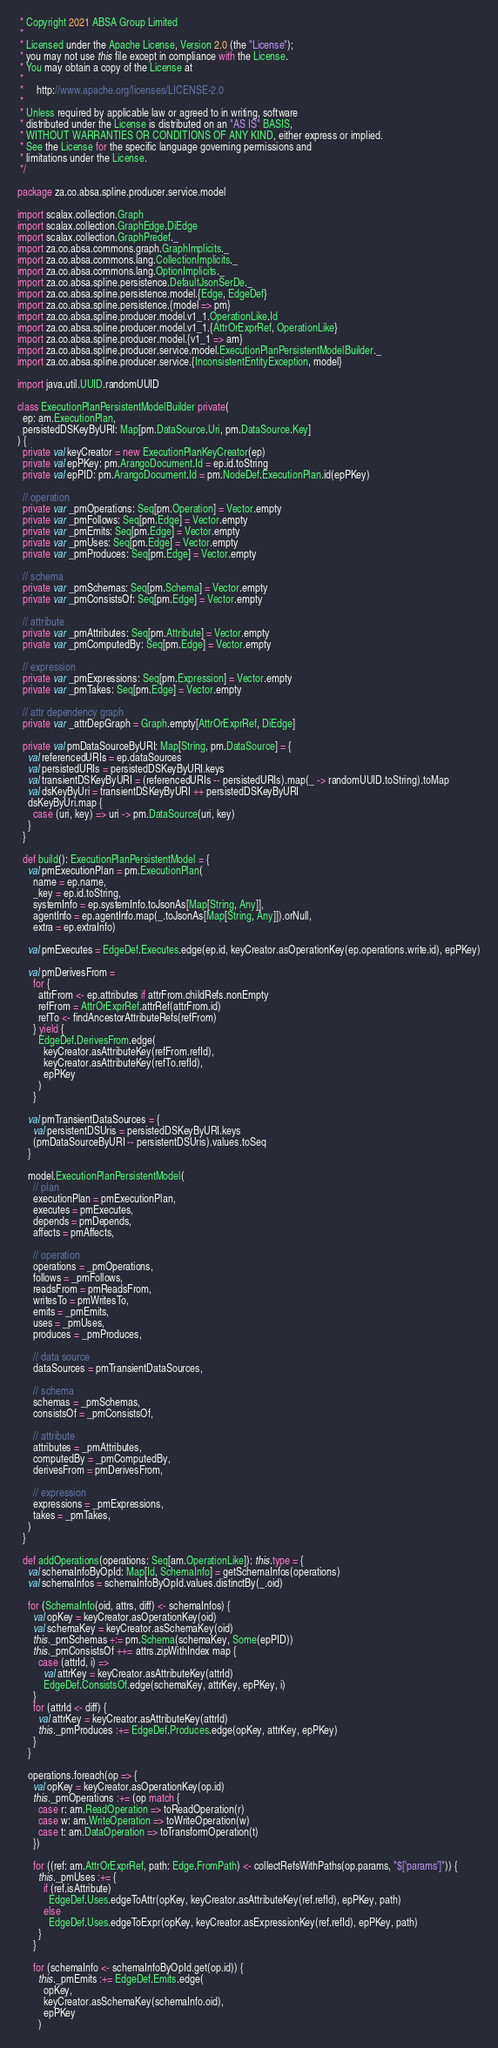<code> <loc_0><loc_0><loc_500><loc_500><_Scala_> * Copyright 2021 ABSA Group Limited
 *
 * Licensed under the Apache License, Version 2.0 (the "License");
 * you may not use this file except in compliance with the License.
 * You may obtain a copy of the License at
 *
 *     http://www.apache.org/licenses/LICENSE-2.0
 *
 * Unless required by applicable law or agreed to in writing, software
 * distributed under the License is distributed on an "AS IS" BASIS,
 * WITHOUT WARRANTIES OR CONDITIONS OF ANY KIND, either express or implied.
 * See the License for the specific language governing permissions and
 * limitations under the License.
 */

package za.co.absa.spline.producer.service.model

import scalax.collection.Graph
import scalax.collection.GraphEdge.DiEdge
import scalax.collection.GraphPredef._
import za.co.absa.commons.graph.GraphImplicits._
import za.co.absa.commons.lang.CollectionImplicits._
import za.co.absa.commons.lang.OptionImplicits._
import za.co.absa.spline.persistence.DefaultJsonSerDe._
import za.co.absa.spline.persistence.model.{Edge, EdgeDef}
import za.co.absa.spline.persistence.{model => pm}
import za.co.absa.spline.producer.model.v1_1.OperationLike.Id
import za.co.absa.spline.producer.model.v1_1.{AttrOrExprRef, OperationLike}
import za.co.absa.spline.producer.model.{v1_1 => am}
import za.co.absa.spline.producer.service.model.ExecutionPlanPersistentModelBuilder._
import za.co.absa.spline.producer.service.{InconsistentEntityException, model}

import java.util.UUID.randomUUID

class ExecutionPlanPersistentModelBuilder private(
  ep: am.ExecutionPlan,
  persistedDSKeyByURI: Map[pm.DataSource.Uri, pm.DataSource.Key]
) {
  private val keyCreator = new ExecutionPlanKeyCreator(ep)
  private val epPKey: pm.ArangoDocument.Id = ep.id.toString
  private val epPID: pm.ArangoDocument.Id = pm.NodeDef.ExecutionPlan.id(epPKey)

  // operation
  private var _pmOperations: Seq[pm.Operation] = Vector.empty
  private var _pmFollows: Seq[pm.Edge] = Vector.empty
  private var _pmEmits: Seq[pm.Edge] = Vector.empty
  private var _pmUses: Seq[pm.Edge] = Vector.empty
  private var _pmProduces: Seq[pm.Edge] = Vector.empty

  // schema
  private var _pmSchemas: Seq[pm.Schema] = Vector.empty
  private var _pmConsistsOf: Seq[pm.Edge] = Vector.empty

  // attribute
  private var _pmAttributes: Seq[pm.Attribute] = Vector.empty
  private var _pmComputedBy: Seq[pm.Edge] = Vector.empty

  // expression
  private var _pmExpressions: Seq[pm.Expression] = Vector.empty
  private var _pmTakes: Seq[pm.Edge] = Vector.empty

  // attr dependency graph
  private var _attrDepGraph = Graph.empty[AttrOrExprRef, DiEdge]

  private val pmDataSourceByURI: Map[String, pm.DataSource] = {
    val referencedURIs = ep.dataSources
    val persistedURIs = persistedDSKeyByURI.keys
    val transientDSKeyByURI = (referencedURIs -- persistedURIs).map(_ -> randomUUID.toString).toMap
    val dsKeyByUri = transientDSKeyByURI ++ persistedDSKeyByURI
    dsKeyByUri.map {
      case (uri, key) => uri -> pm.DataSource(uri, key)
    }
  }

  def build(): ExecutionPlanPersistentModel = {
    val pmExecutionPlan = pm.ExecutionPlan(
      name = ep.name,
      _key = ep.id.toString,
      systemInfo = ep.systemInfo.toJsonAs[Map[String, Any]],
      agentInfo = ep.agentInfo.map(_.toJsonAs[Map[String, Any]]).orNull,
      extra = ep.extraInfo)

    val pmExecutes = EdgeDef.Executes.edge(ep.id, keyCreator.asOperationKey(ep.operations.write.id), epPKey)

    val pmDerivesFrom =
      for {
        attrFrom <- ep.attributes if attrFrom.childRefs.nonEmpty
        refFrom = AttrOrExprRef.attrRef(attrFrom.id)
        refTo <- findAncestorAttributeRefs(refFrom)
      } yield {
        EdgeDef.DerivesFrom.edge(
          keyCreator.asAttributeKey(refFrom.refId),
          keyCreator.asAttributeKey(refTo.refId),
          epPKey
        )
      }

    val pmTransientDataSources = {
      val persistentDSUris = persistedDSKeyByURI.keys
      (pmDataSourceByURI -- persistentDSUris).values.toSeq
    }

    model.ExecutionPlanPersistentModel(
      // plan
      executionPlan = pmExecutionPlan,
      executes = pmExecutes,
      depends = pmDepends,
      affects = pmAffects,

      // operation
      operations = _pmOperations,
      follows = _pmFollows,
      readsFrom = pmReadsFrom,
      writesTo = pmWritesTo,
      emits = _pmEmits,
      uses = _pmUses,
      produces = _pmProduces,

      // data source
      dataSources = pmTransientDataSources,

      // schema
      schemas = _pmSchemas,
      consistsOf = _pmConsistsOf,

      // attribute
      attributes = _pmAttributes,
      computedBy = _pmComputedBy,
      derivesFrom = pmDerivesFrom,

      // expression
      expressions = _pmExpressions,
      takes = _pmTakes,
    )
  }

  def addOperations(operations: Seq[am.OperationLike]): this.type = {
    val schemaInfoByOpId: Map[Id, SchemaInfo] = getSchemaInfos(operations)
    val schemaInfos = schemaInfoByOpId.values.distinctBy(_.oid)

    for (SchemaInfo(oid, attrs, diff) <- schemaInfos) {
      val opKey = keyCreator.asOperationKey(oid)
      val schemaKey = keyCreator.asSchemaKey(oid)
      this._pmSchemas +:= pm.Schema(schemaKey, Some(epPID))
      this._pmConsistsOf ++= attrs.zipWithIndex map {
        case (attrId, i) =>
          val attrKey = keyCreator.asAttributeKey(attrId)
          EdgeDef.ConsistsOf.edge(schemaKey, attrKey, epPKey, i)
      }
      for (attrId <- diff) {
        val attrKey = keyCreator.asAttributeKey(attrId)
        this._pmProduces :+= EdgeDef.Produces.edge(opKey, attrKey, epPKey)
      }
    }

    operations.foreach(op => {
      val opKey = keyCreator.asOperationKey(op.id)
      this._pmOperations :+= (op match {
        case r: am.ReadOperation => toReadOperation(r)
        case w: am.WriteOperation => toWriteOperation(w)
        case t: am.DataOperation => toTransformOperation(t)
      })

      for ((ref: am.AttrOrExprRef, path: Edge.FromPath) <- collectRefsWithPaths(op.params, "$['params']")) {
        this._pmUses :+= {
          if (ref.isAttribute)
            EdgeDef.Uses.edgeToAttr(opKey, keyCreator.asAttributeKey(ref.refId), epPKey, path)
          else
            EdgeDef.Uses.edgeToExpr(opKey, keyCreator.asExpressionKey(ref.refId), epPKey, path)
        }
      }

      for (schemaInfo <- schemaInfoByOpId.get(op.id)) {
        this._pmEmits :+= EdgeDef.Emits.edge(
          opKey,
          keyCreator.asSchemaKey(schemaInfo.oid),
          epPKey
        )</code> 